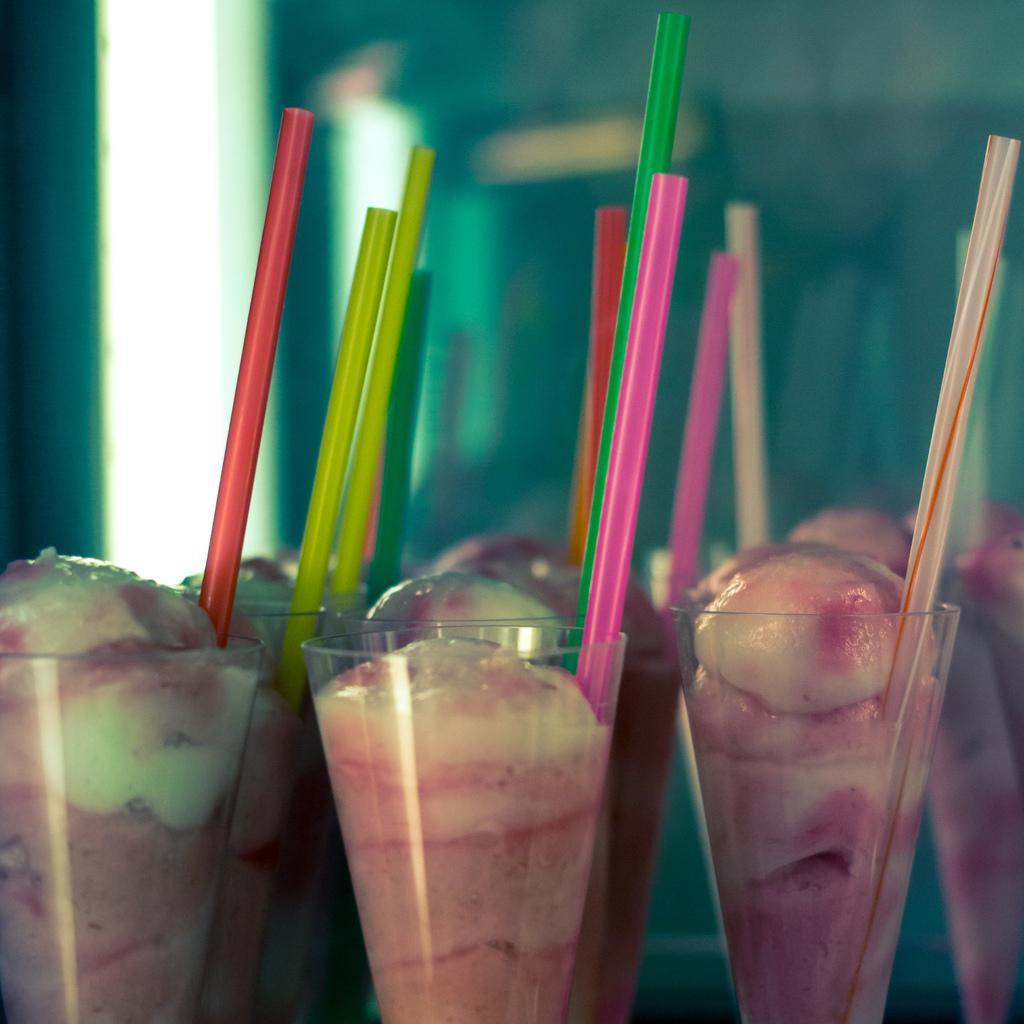Please provide a concise description of this image. In this image we can see food items and straws in the glasses. The background of the image is blurred. 